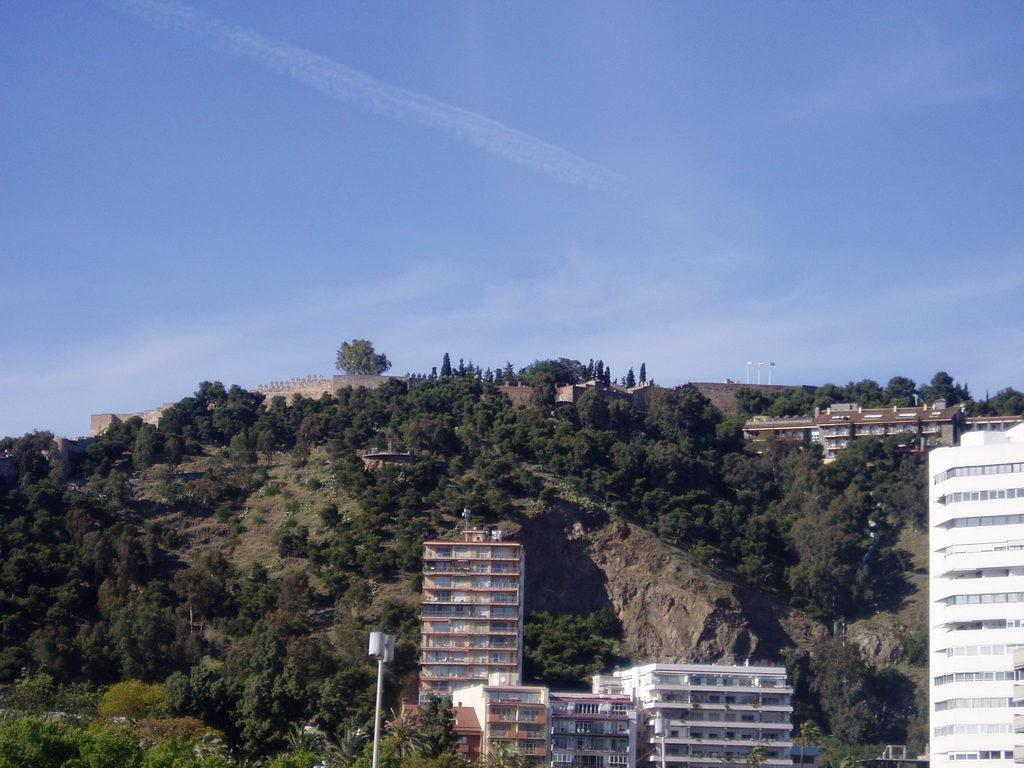What type of natural feature can be seen in the image? There is a group of trees in the image. What type of man-made structures are visible in the image? There are buildings with windows in the image. Where is the street lamp located in the image? The street lamp is present on a hill. What is visible in the sky in the image? The sky is visible in the image. What is the weather like in the image? The sky appears to be cloudy in the image. Can you tell me how many zippers are visible on the trees in the image? There are no zippers present on the trees in the image. What type of actor can be seen performing on the hill in the image? There are no actors or performances depicted in the image; it features a street lamp on a hill. 